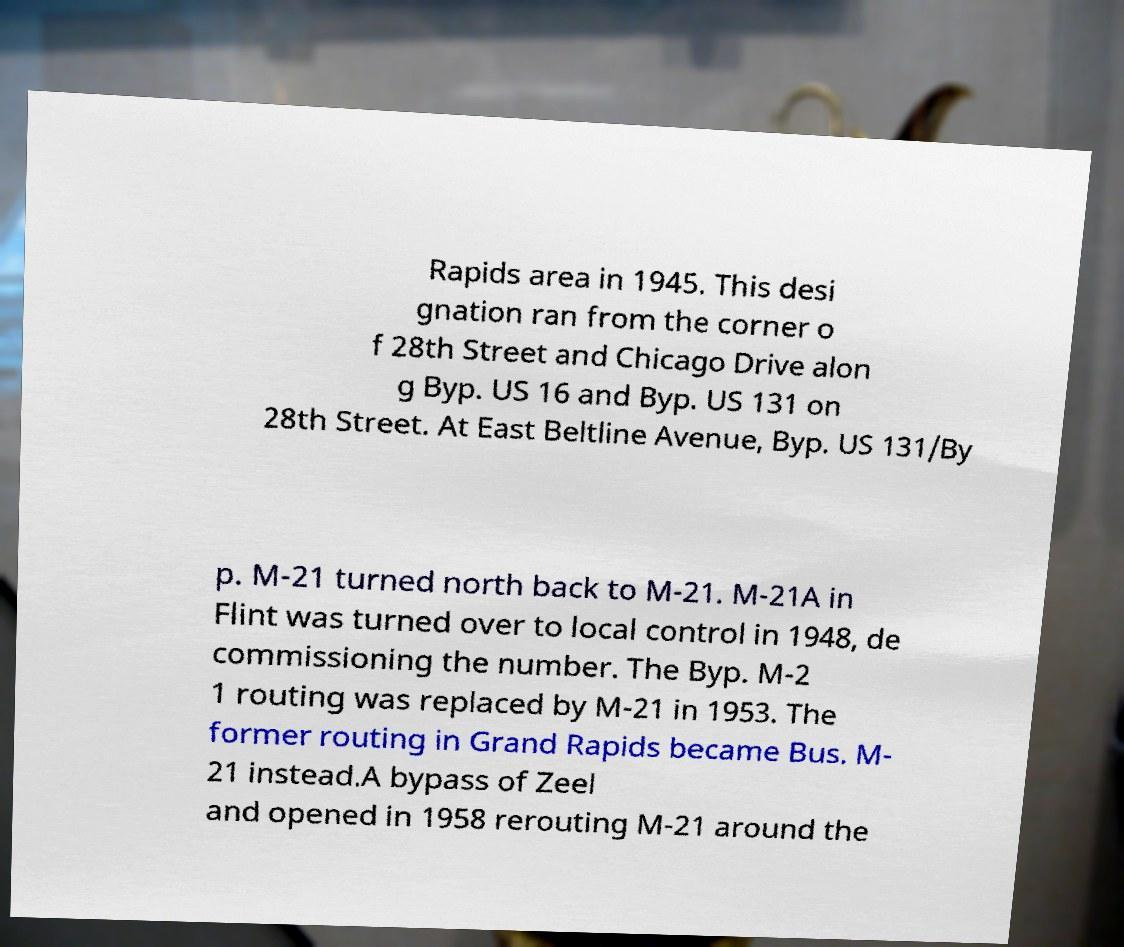Could you assist in decoding the text presented in this image and type it out clearly? Rapids area in 1945. This desi gnation ran from the corner o f 28th Street and Chicago Drive alon g Byp. US 16 and Byp. US 131 on 28th Street. At East Beltline Avenue, Byp. US 131/By p. M-21 turned north back to M-21. M-21A in Flint was turned over to local control in 1948, de commissioning the number. The Byp. M-2 1 routing was replaced by M-21 in 1953. The former routing in Grand Rapids became Bus. M- 21 instead.A bypass of Zeel and opened in 1958 rerouting M-21 around the 